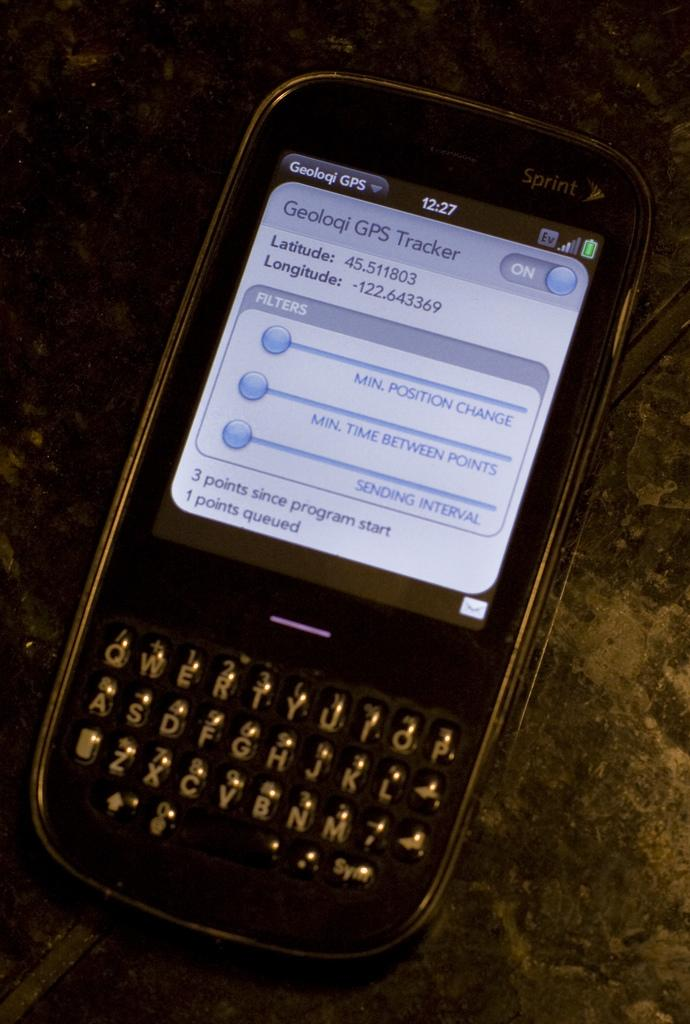Provide a one-sentence caption for the provided image. A phone with a Geoloqi GPS Tracker pulled up on the screen. 